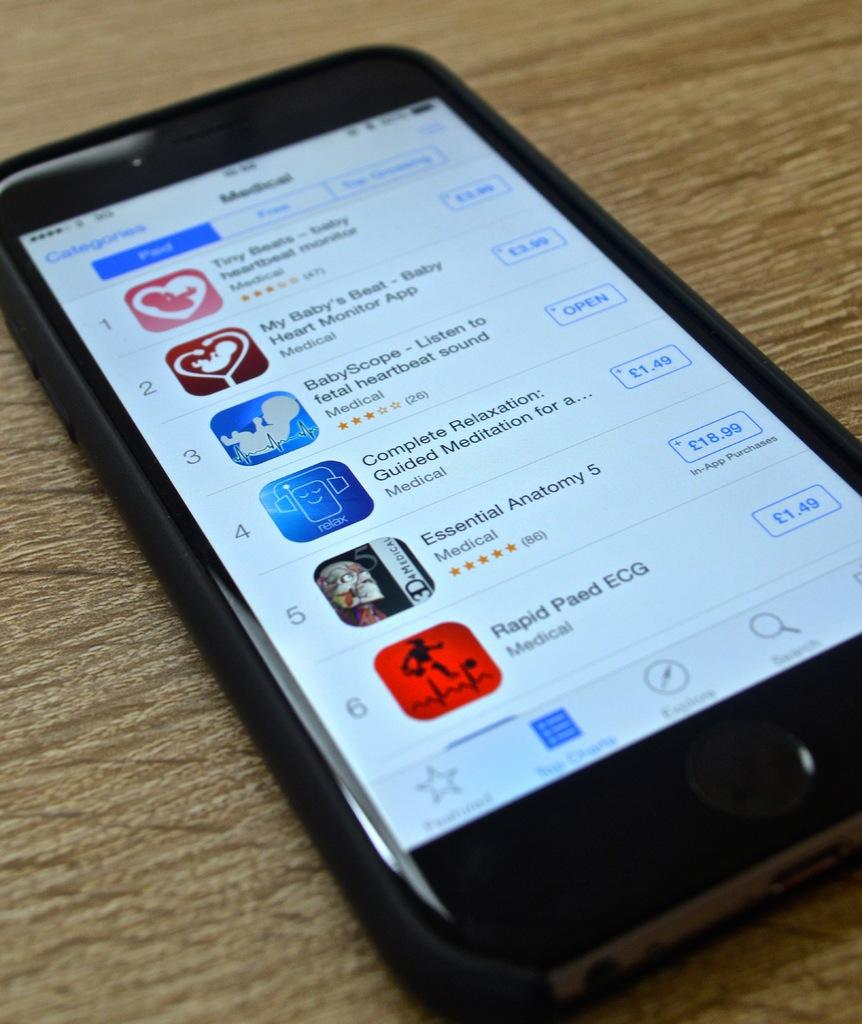<image>
Share a concise interpretation of the image provided. Black phone with an app called Rapid Paed ECG on the bottom. 